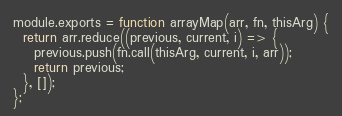<code> <loc_0><loc_0><loc_500><loc_500><_JavaScript_>module.exports = function arrayMap(arr, fn, thisArg) {
  return arr.reduce((previous, current, i) => {
    previous.push(fn.call(thisArg, current, i, arr));
    return previous;
  }, []);
};
</code> 